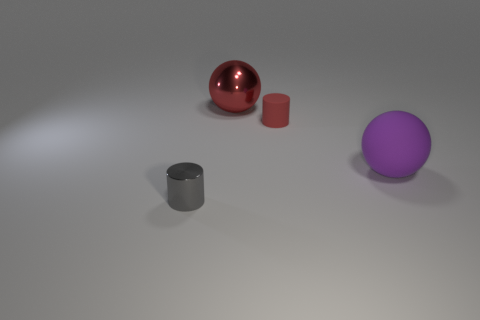Subtract all brown balls. Subtract all cyan cubes. How many balls are left? 2 Subtract all gray cylinders. How many yellow spheres are left? 0 Add 2 big purples. How many things exist? 0 Subtract all big balls. Subtract all large red shiny balls. How many objects are left? 1 Add 4 big red shiny balls. How many big red shiny balls are left? 5 Add 2 large red balls. How many large red balls exist? 3 Add 1 gray cylinders. How many objects exist? 5 Subtract all red cylinders. How many cylinders are left? 1 Subtract 0 yellow cylinders. How many objects are left? 4 Subtract 2 cylinders. How many cylinders are left? 0 